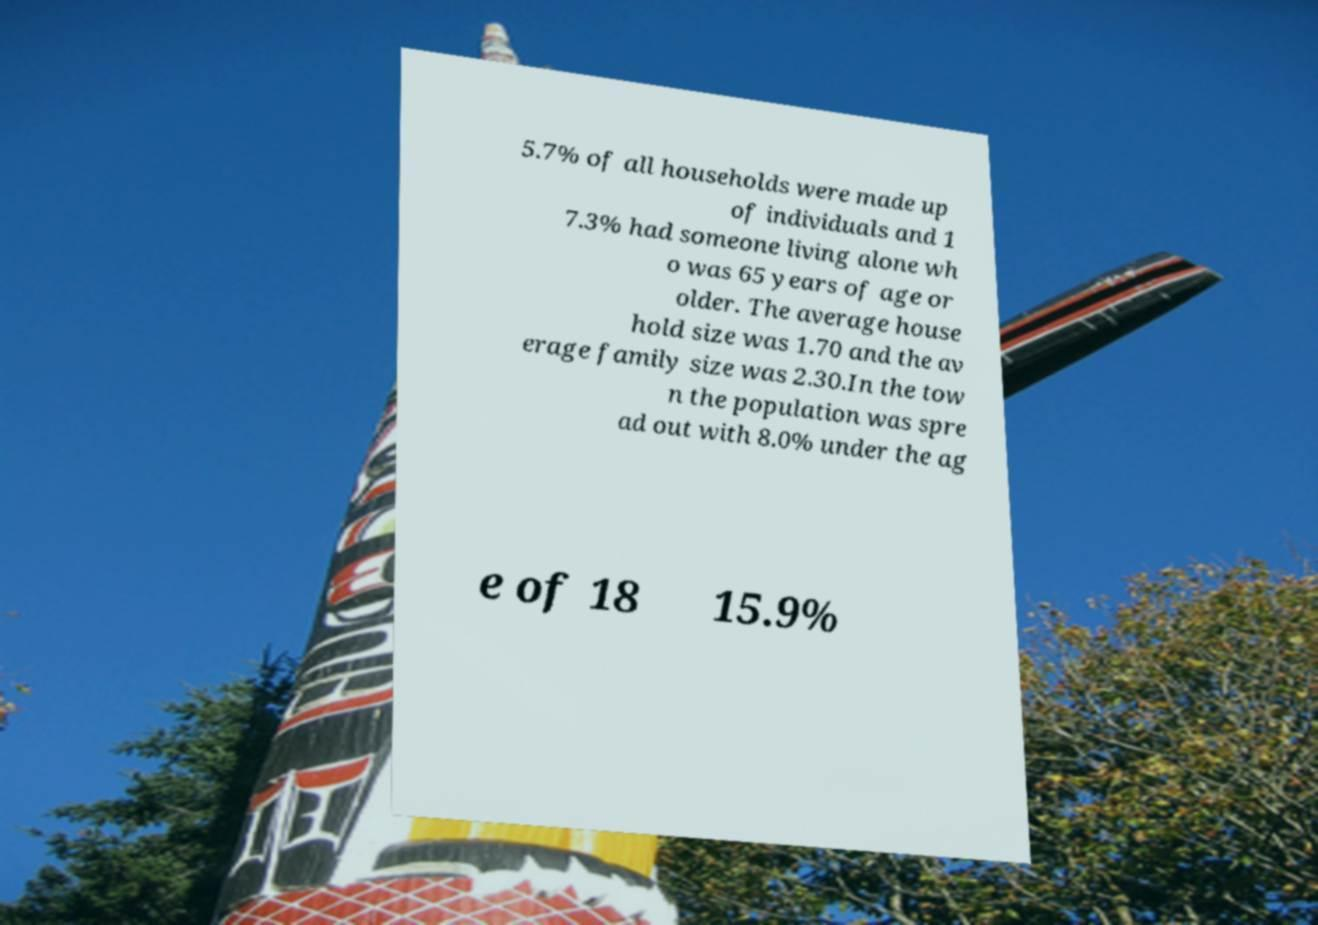There's text embedded in this image that I need extracted. Can you transcribe it verbatim? 5.7% of all households were made up of individuals and 1 7.3% had someone living alone wh o was 65 years of age or older. The average house hold size was 1.70 and the av erage family size was 2.30.In the tow n the population was spre ad out with 8.0% under the ag e of 18 15.9% 